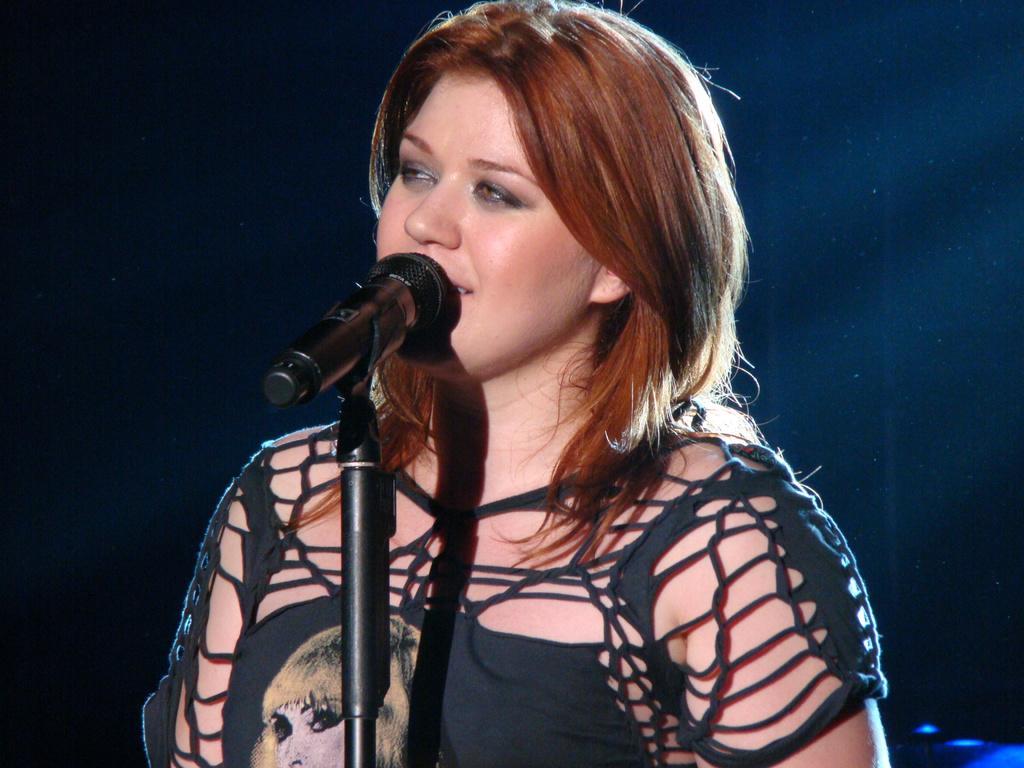Could you give a brief overview of what you see in this image? In this image the background is dark. In the middle of the image there is a girl and there is a mic. 